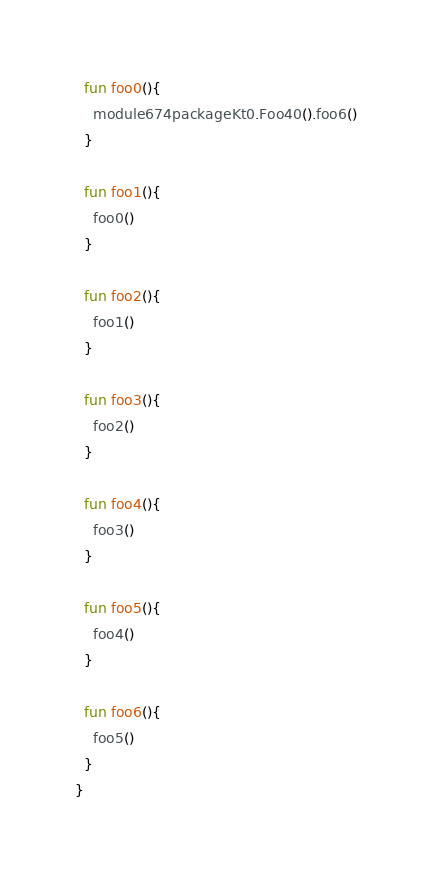Convert code to text. <code><loc_0><loc_0><loc_500><loc_500><_Kotlin_>
  fun foo0(){
    module674packageKt0.Foo40().foo6()
  }

  fun foo1(){
    foo0()
  }

  fun foo2(){
    foo1()
  }

  fun foo3(){
    foo2()
  }

  fun foo4(){
    foo3()
  }

  fun foo5(){
    foo4()
  }

  fun foo6(){
    foo5()
  }
}</code> 